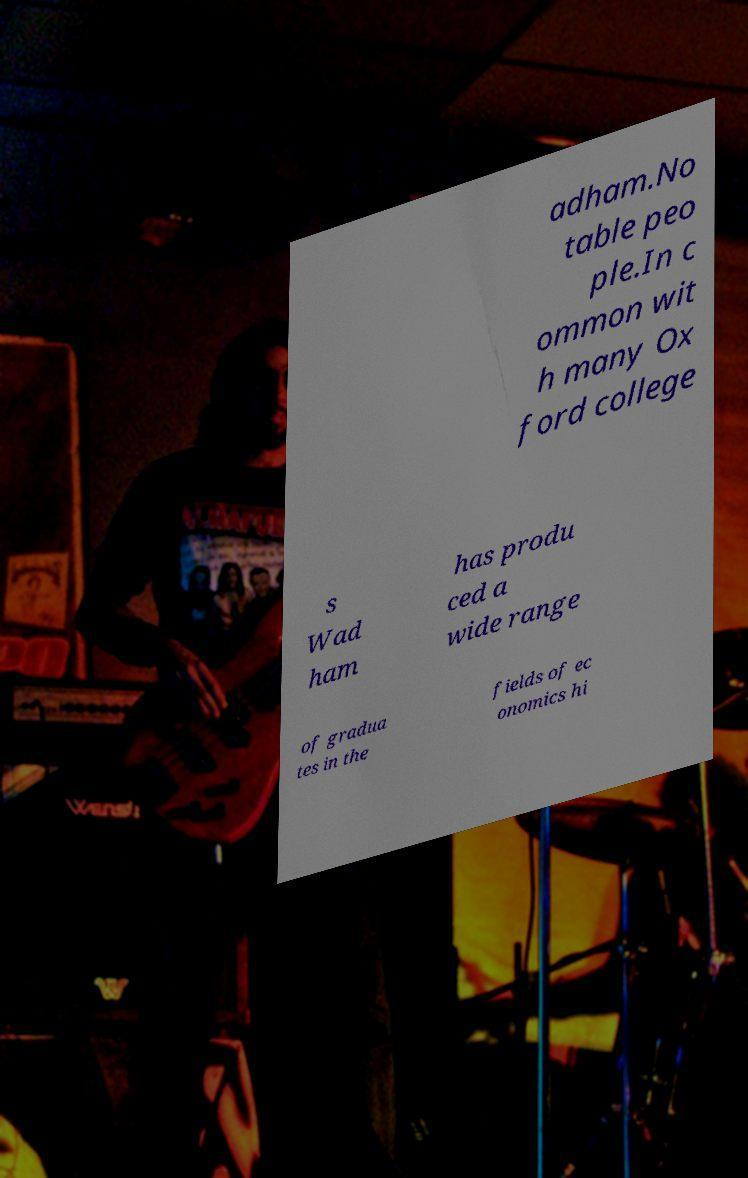Could you extract and type out the text from this image? adham.No table peo ple.In c ommon wit h many Ox ford college s Wad ham has produ ced a wide range of gradua tes in the fields of ec onomics hi 